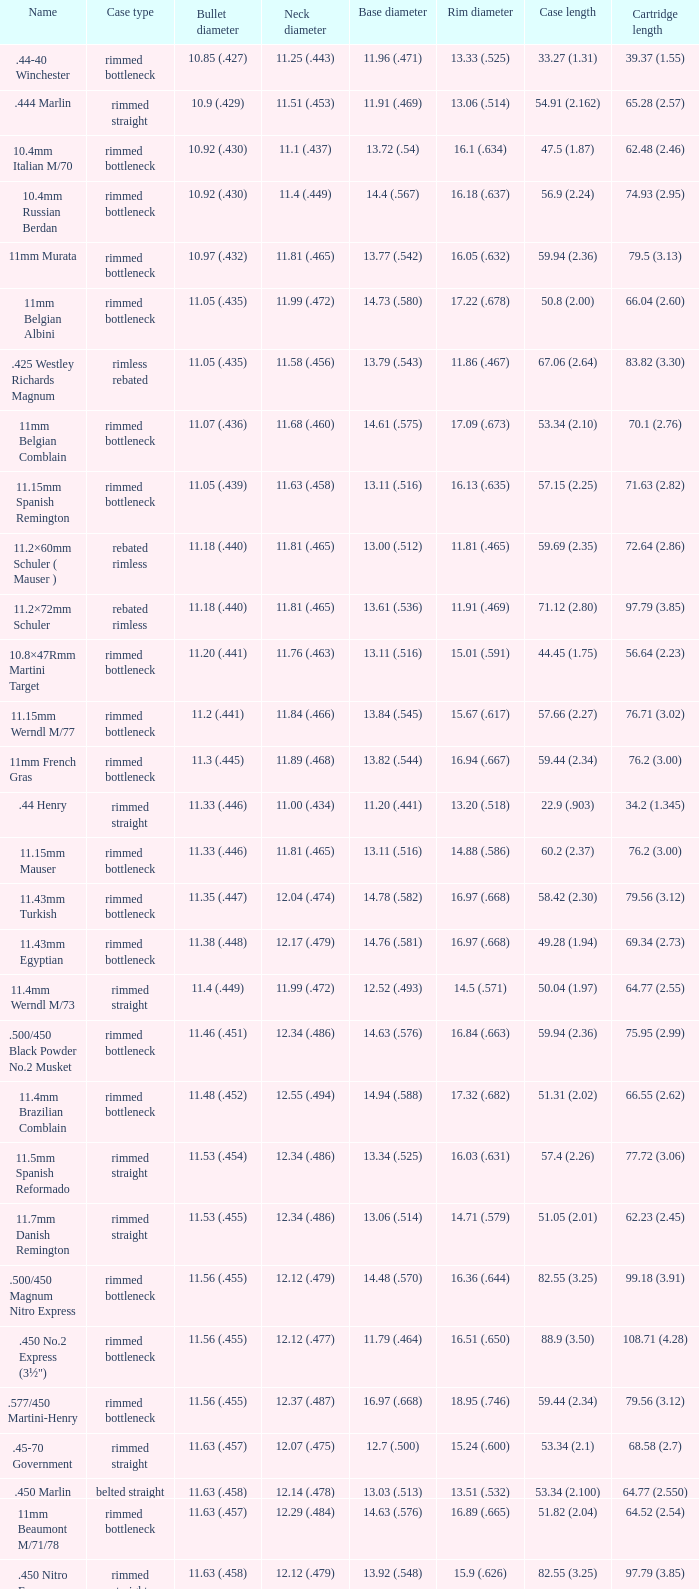Which Bullet diameter has a Name of 11.4mm werndl m/73? 11.4 (.449). 